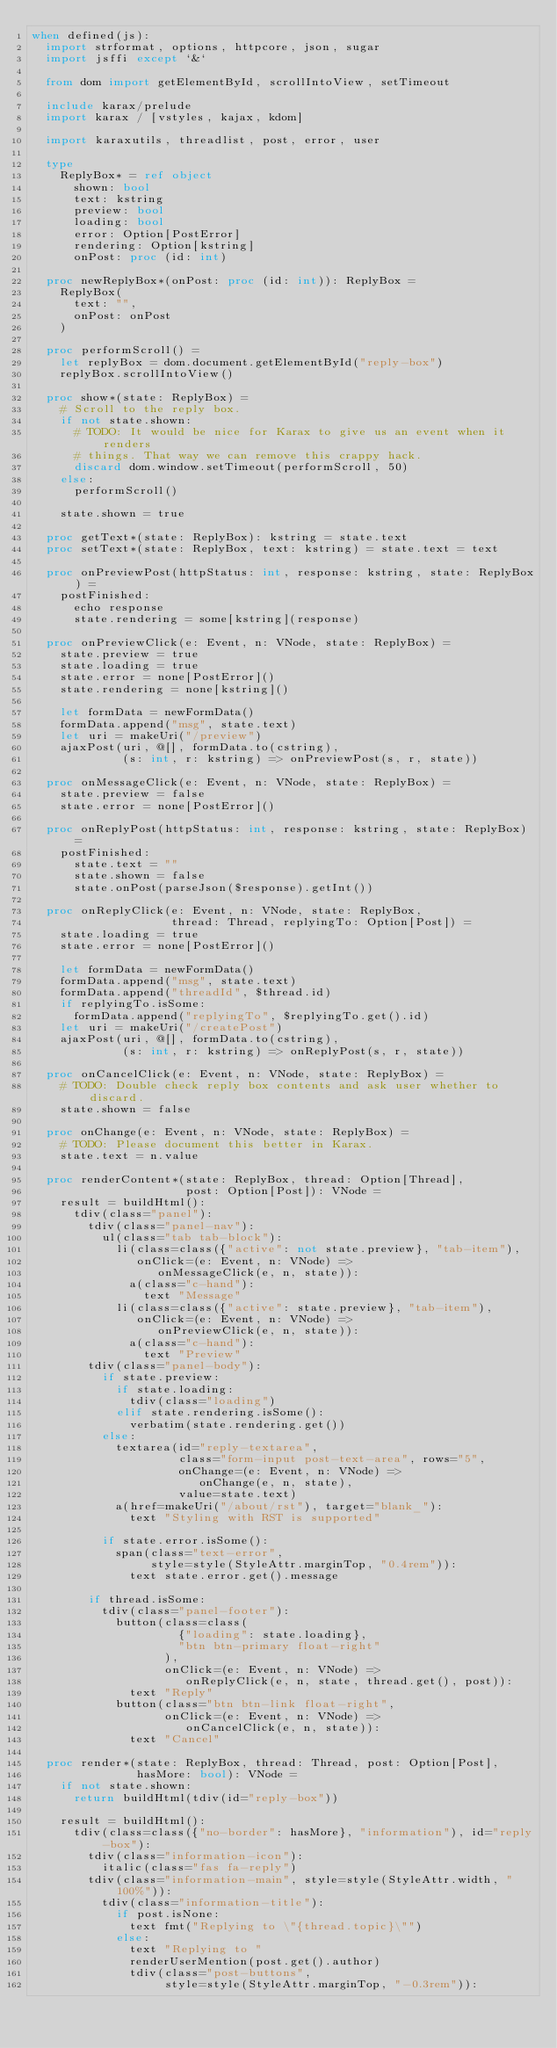Convert code to text. <code><loc_0><loc_0><loc_500><loc_500><_Nim_>when defined(js):
  import strformat, options, httpcore, json, sugar
  import jsffi except `&`

  from dom import getElementById, scrollIntoView, setTimeout

  include karax/prelude
  import karax / [vstyles, kajax, kdom]

  import karaxutils, threadlist, post, error, user

  type
    ReplyBox* = ref object
      shown: bool
      text: kstring
      preview: bool
      loading: bool
      error: Option[PostError]
      rendering: Option[kstring]
      onPost: proc (id: int)

  proc newReplyBox*(onPost: proc (id: int)): ReplyBox =
    ReplyBox(
      text: "",
      onPost: onPost
    )

  proc performScroll() =
    let replyBox = dom.document.getElementById("reply-box")
    replyBox.scrollIntoView()

  proc show*(state: ReplyBox) =
    # Scroll to the reply box.
    if not state.shown:
      # TODO: It would be nice for Karax to give us an event when it renders
      # things. That way we can remove this crappy hack.
      discard dom.window.setTimeout(performScroll, 50)
    else:
      performScroll()

    state.shown = true

  proc getText*(state: ReplyBox): kstring = state.text
  proc setText*(state: ReplyBox, text: kstring) = state.text = text

  proc onPreviewPost(httpStatus: int, response: kstring, state: ReplyBox) =
    postFinished:
      echo response
      state.rendering = some[kstring](response)

  proc onPreviewClick(e: Event, n: VNode, state: ReplyBox) =
    state.preview = true
    state.loading = true
    state.error = none[PostError]()
    state.rendering = none[kstring]()

    let formData = newFormData()
    formData.append("msg", state.text)
    let uri = makeUri("/preview")
    ajaxPost(uri, @[], formData.to(cstring),
             (s: int, r: kstring) => onPreviewPost(s, r, state))

  proc onMessageClick(e: Event, n: VNode, state: ReplyBox) =
    state.preview = false
    state.error = none[PostError]()

  proc onReplyPost(httpStatus: int, response: kstring, state: ReplyBox) =
    postFinished:
      state.text = ""
      state.shown = false
      state.onPost(parseJson($response).getInt())

  proc onReplyClick(e: Event, n: VNode, state: ReplyBox,
                    thread: Thread, replyingTo: Option[Post]) =
    state.loading = true
    state.error = none[PostError]()

    let formData = newFormData()
    formData.append("msg", state.text)
    formData.append("threadId", $thread.id)
    if replyingTo.isSome:
      formData.append("replyingTo", $replyingTo.get().id)
    let uri = makeUri("/createPost")
    ajaxPost(uri, @[], formData.to(cstring),
             (s: int, r: kstring) => onReplyPost(s, r, state))

  proc onCancelClick(e: Event, n: VNode, state: ReplyBox) =
    # TODO: Double check reply box contents and ask user whether to discard.
    state.shown = false

  proc onChange(e: Event, n: VNode, state: ReplyBox) =
    # TODO: Please document this better in Karax.
    state.text = n.value

  proc renderContent*(state: ReplyBox, thread: Option[Thread],
                      post: Option[Post]): VNode =
    result = buildHtml():
      tdiv(class="panel"):
        tdiv(class="panel-nav"):
          ul(class="tab tab-block"):
            li(class=class({"active": not state.preview}, "tab-item"),
               onClick=(e: Event, n: VNode) =>
                  onMessageClick(e, n, state)):
              a(class="c-hand"):
                text "Message"
            li(class=class({"active": state.preview}, "tab-item"),
               onClick=(e: Event, n: VNode) =>
                  onPreviewClick(e, n, state)):
              a(class="c-hand"):
                text "Preview"
        tdiv(class="panel-body"):
          if state.preview:
            if state.loading:
              tdiv(class="loading")
            elif state.rendering.isSome():
              verbatim(state.rendering.get())
          else:
            textarea(id="reply-textarea",
                     class="form-input post-text-area", rows="5",
                     onChange=(e: Event, n: VNode) =>
                        onChange(e, n, state),
                     value=state.text)
            a(href=makeUri("/about/rst"), target="blank_"):
              text "Styling with RST is supported"

          if state.error.isSome():
            span(class="text-error",
                 style=style(StyleAttr.marginTop, "0.4rem")):
              text state.error.get().message

        if thread.isSome:
          tdiv(class="panel-footer"):
            button(class=class(
                     {"loading": state.loading},
                     "btn btn-primary float-right"
                   ),
                   onClick=(e: Event, n: VNode) =>
                      onReplyClick(e, n, state, thread.get(), post)):
              text "Reply"
            button(class="btn btn-link float-right",
                   onClick=(e: Event, n: VNode) =>
                      onCancelClick(e, n, state)):
              text "Cancel"

  proc render*(state: ReplyBox, thread: Thread, post: Option[Post],
               hasMore: bool): VNode =
    if not state.shown:
      return buildHtml(tdiv(id="reply-box"))

    result = buildHtml():
      tdiv(class=class({"no-border": hasMore}, "information"), id="reply-box"):
        tdiv(class="information-icon"):
          italic(class="fas fa-reply")
        tdiv(class="information-main", style=style(StyleAttr.width, "100%")):
          tdiv(class="information-title"):
            if post.isNone:
              text fmt("Replying to \"{thread.topic}\"")
            else:
              text "Replying to "
              renderUserMention(post.get().author)
              tdiv(class="post-buttons",
                   style=style(StyleAttr.marginTop, "-0.3rem")):</code> 